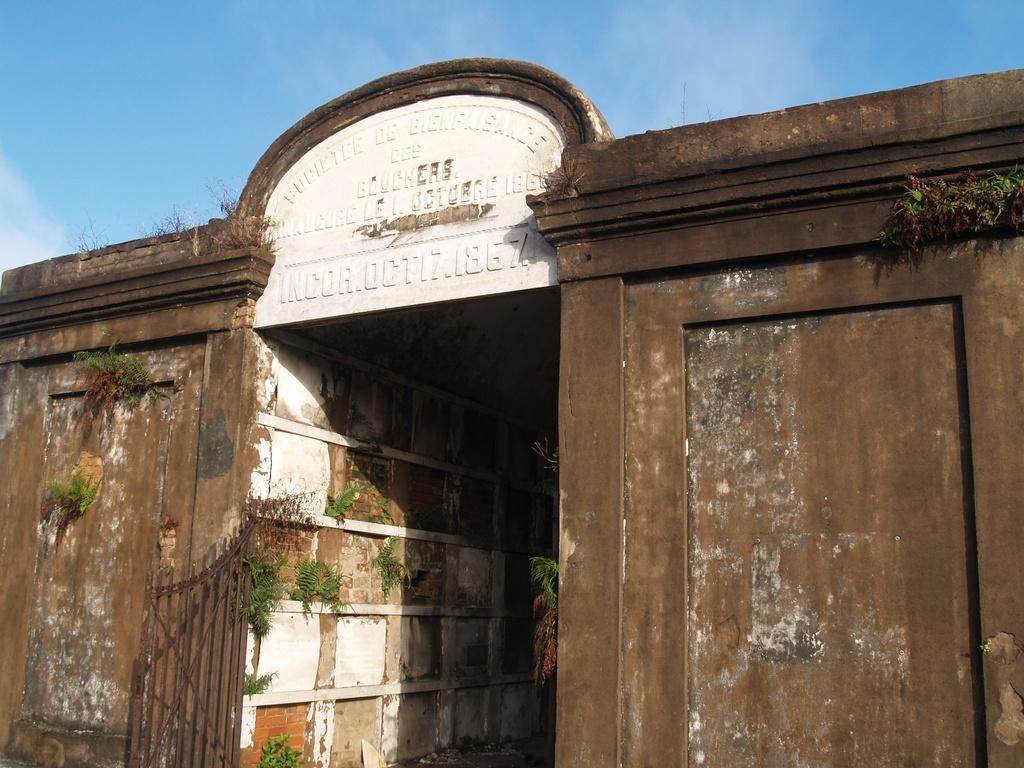In one or two sentences, can you explain what this image depicts? In this image I can see a building and I can see a gate and the plants. In the middle of this picture I see something is written. In the background I can see the clear sky. 